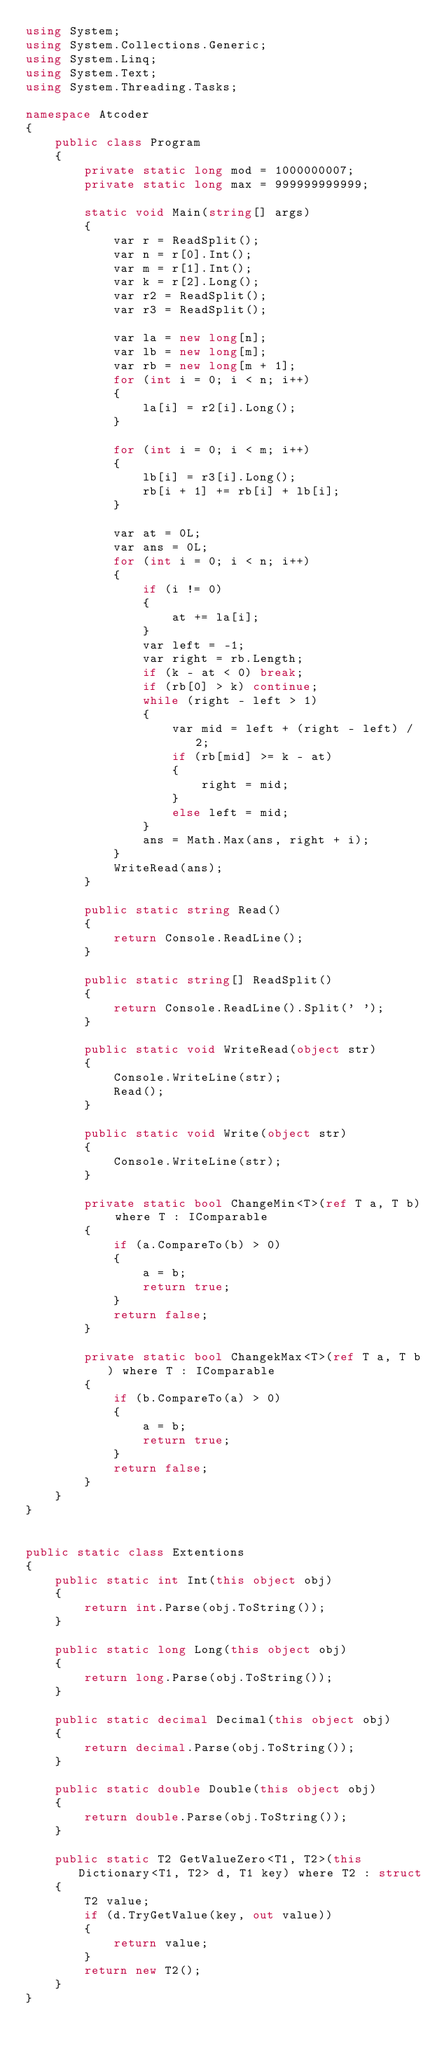<code> <loc_0><loc_0><loc_500><loc_500><_C#_>using System;
using System.Collections.Generic;
using System.Linq;
using System.Text;
using System.Threading.Tasks;

namespace Atcoder
{
    public class Program
    {
        private static long mod = 1000000007;
        private static long max = 999999999999;

        static void Main(string[] args)
        {
            var r = ReadSplit();
            var n = r[0].Int();
            var m = r[1].Int();
            var k = r[2].Long();
            var r2 = ReadSplit();
            var r3 = ReadSplit();

            var la = new long[n];
            var lb = new long[m];
            var rb = new long[m + 1];
            for (int i = 0; i < n; i++)
            {
                la[i] = r2[i].Long();
            }

            for (int i = 0; i < m; i++)
            {
                lb[i] = r3[i].Long();
                rb[i + 1] += rb[i] + lb[i];
            }

            var at = 0L;
            var ans = 0L;
            for (int i = 0; i < n; i++)
            {
                if (i != 0)
                {
                    at += la[i];
                }
                var left = -1;
                var right = rb.Length;
                if (k - at < 0) break;
                if (rb[0] > k) continue;
                while (right - left > 1)
                {
                    var mid = left + (right - left) / 2;
                    if (rb[mid] >= k - at)
                    {
                        right = mid;
                    }
                    else left = mid;
                }
                ans = Math.Max(ans, right + i);
            }
            WriteRead(ans);
        }

        public static string Read()
        {
            return Console.ReadLine();
        }

        public static string[] ReadSplit()
        {
            return Console.ReadLine().Split(' ');
        }

        public static void WriteRead(object str)
        {
            Console.WriteLine(str);
            Read();
        }

        public static void Write(object str)
        {
            Console.WriteLine(str);
        }

        private static bool ChangeMin<T>(ref T a, T b) where T : IComparable
        {
            if (a.CompareTo(b) > 0)
            {
                a = b;
                return true;
            }
            return false;
        }

        private static bool ChangekMax<T>(ref T a, T b) where T : IComparable
        {
            if (b.CompareTo(a) > 0)
            {
                a = b;
                return true;
            }
            return false;
        }
    }
}


public static class Extentions
{
    public static int Int(this object obj)
    {
        return int.Parse(obj.ToString());
    }

    public static long Long(this object obj)
    {
        return long.Parse(obj.ToString());
    }

    public static decimal Decimal(this object obj)
    {
        return decimal.Parse(obj.ToString());
    }

    public static double Double(this object obj)
    {
        return double.Parse(obj.ToString());
    }

    public static T2 GetValueZero<T1, T2>(this Dictionary<T1, T2> d, T1 key) where T2 : struct
    {
        T2 value;
        if (d.TryGetValue(key, out value))
        {
            return value;
        }
        return new T2();
    }
}

</code> 